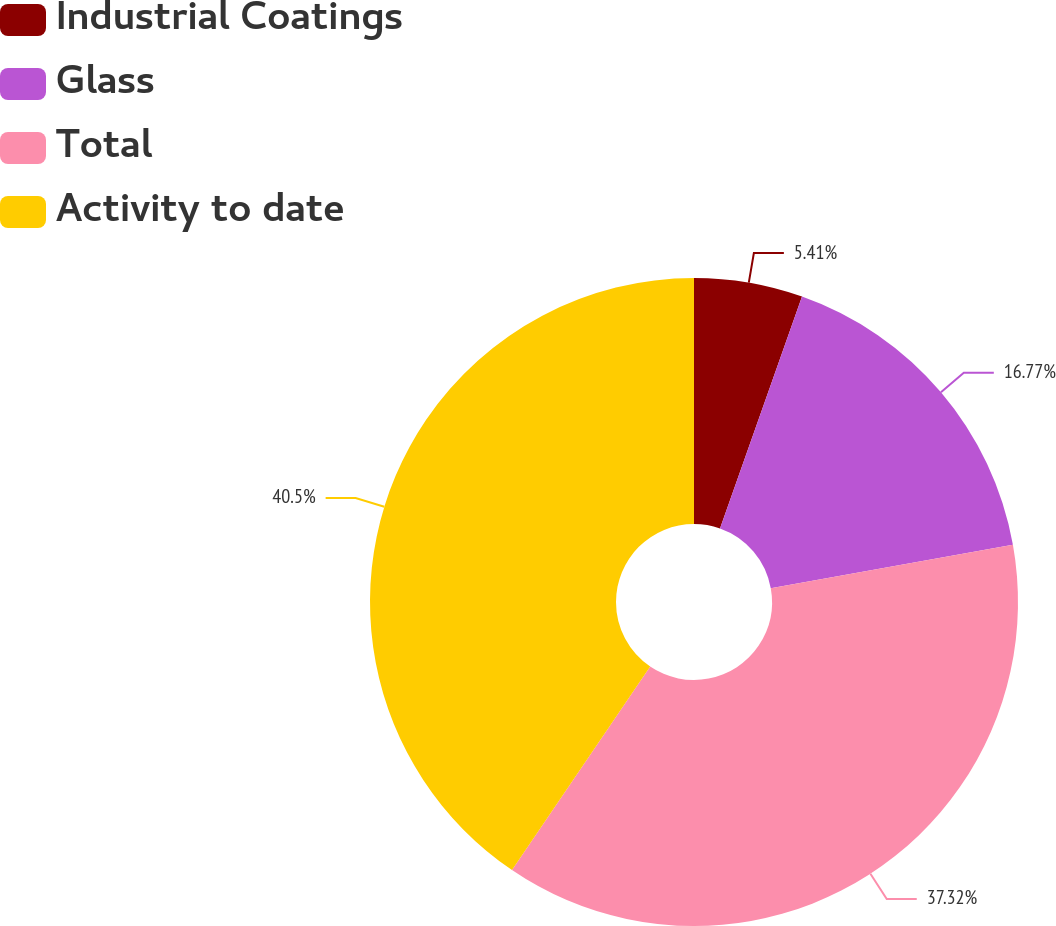Convert chart. <chart><loc_0><loc_0><loc_500><loc_500><pie_chart><fcel>Industrial Coatings<fcel>Glass<fcel>Total<fcel>Activity to date<nl><fcel>5.41%<fcel>16.77%<fcel>37.32%<fcel>40.51%<nl></chart> 